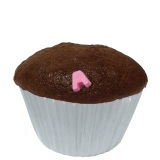Imagine if this cupcake had a secret inside. What could it be? Imagine biting into this cupcake and discovering a hidden center filled with gooey caramel or creamy peanut butter. Alternatively, it could have a surprising burst of fruit jam, like raspberry or cherry, that adds a delightful contrast to the rich chocolate flavor.  If this cupcake could tell a story, what would it say? If this cupcake could tell a story, it might recount its journey from humble ingredients to a delightful treat. It would begin with the mixing of flour, sugar, cocoa, and eggs, creating a smooth, velvety batter. Baked to perfection, it would describe the warmth of the oven and the savory aroma filling the kitchen. Its story would continue with the careful decoration, a single pink heart placed lovingly on top, symbolizing the care and affection with which it was made. This cupcake would speak of joy and celebration, perhaps reminiscing about bringing smiles to faces at a party or providing comfort on a rainy day. 